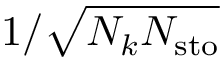Convert formula to latex. <formula><loc_0><loc_0><loc_500><loc_500>1 / \sqrt { N _ { k } N _ { s t o } }</formula> 